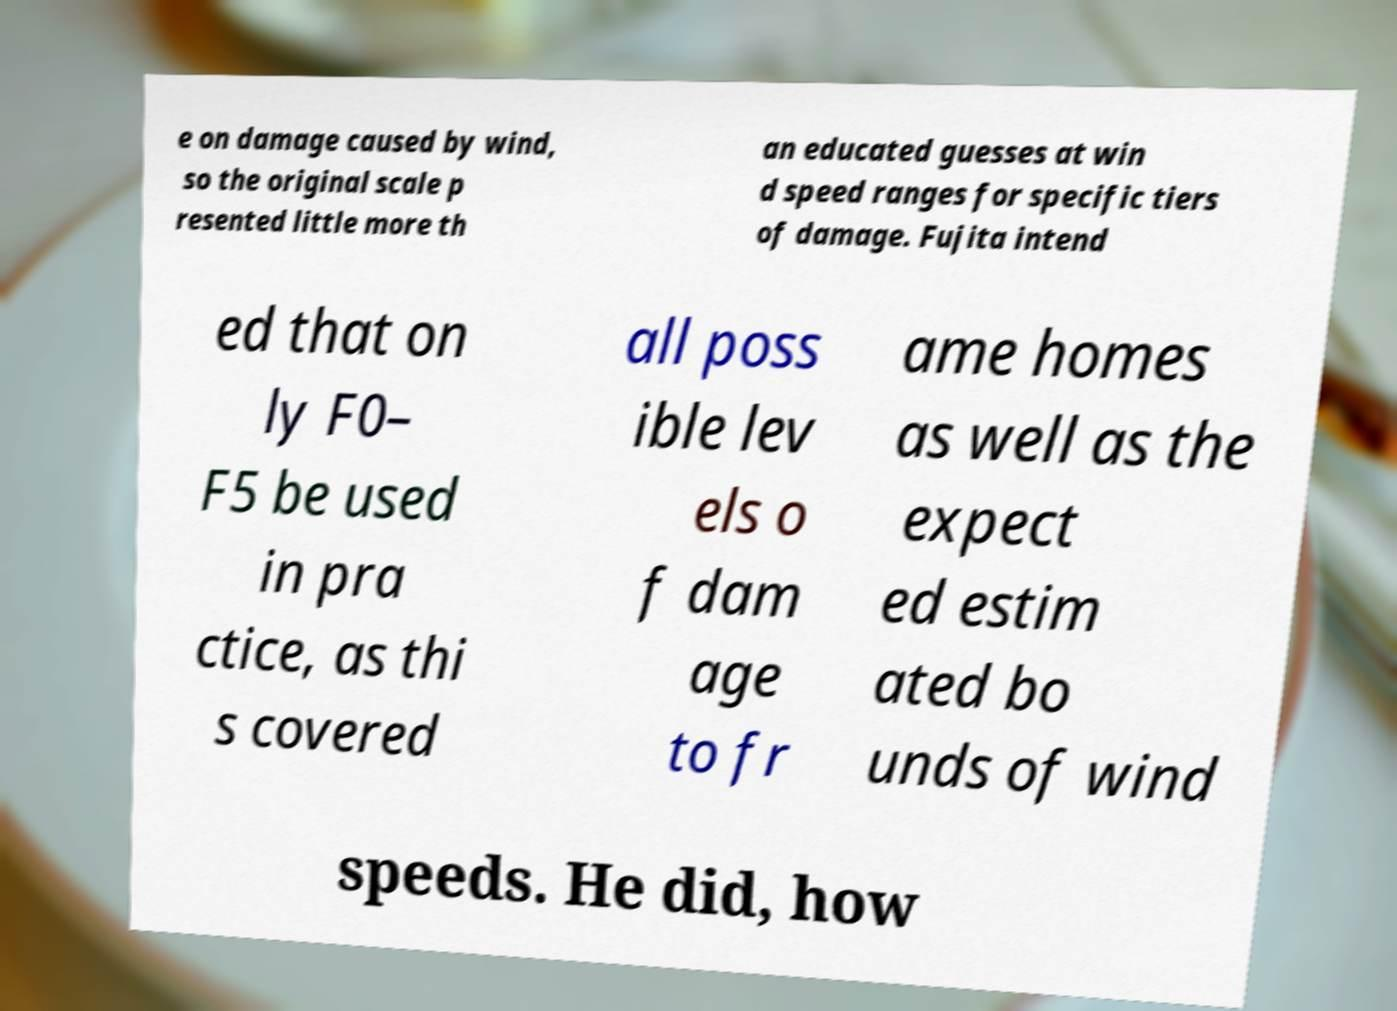There's text embedded in this image that I need extracted. Can you transcribe it verbatim? e on damage caused by wind, so the original scale p resented little more th an educated guesses at win d speed ranges for specific tiers of damage. Fujita intend ed that on ly F0– F5 be used in pra ctice, as thi s covered all poss ible lev els o f dam age to fr ame homes as well as the expect ed estim ated bo unds of wind speeds. He did, how 